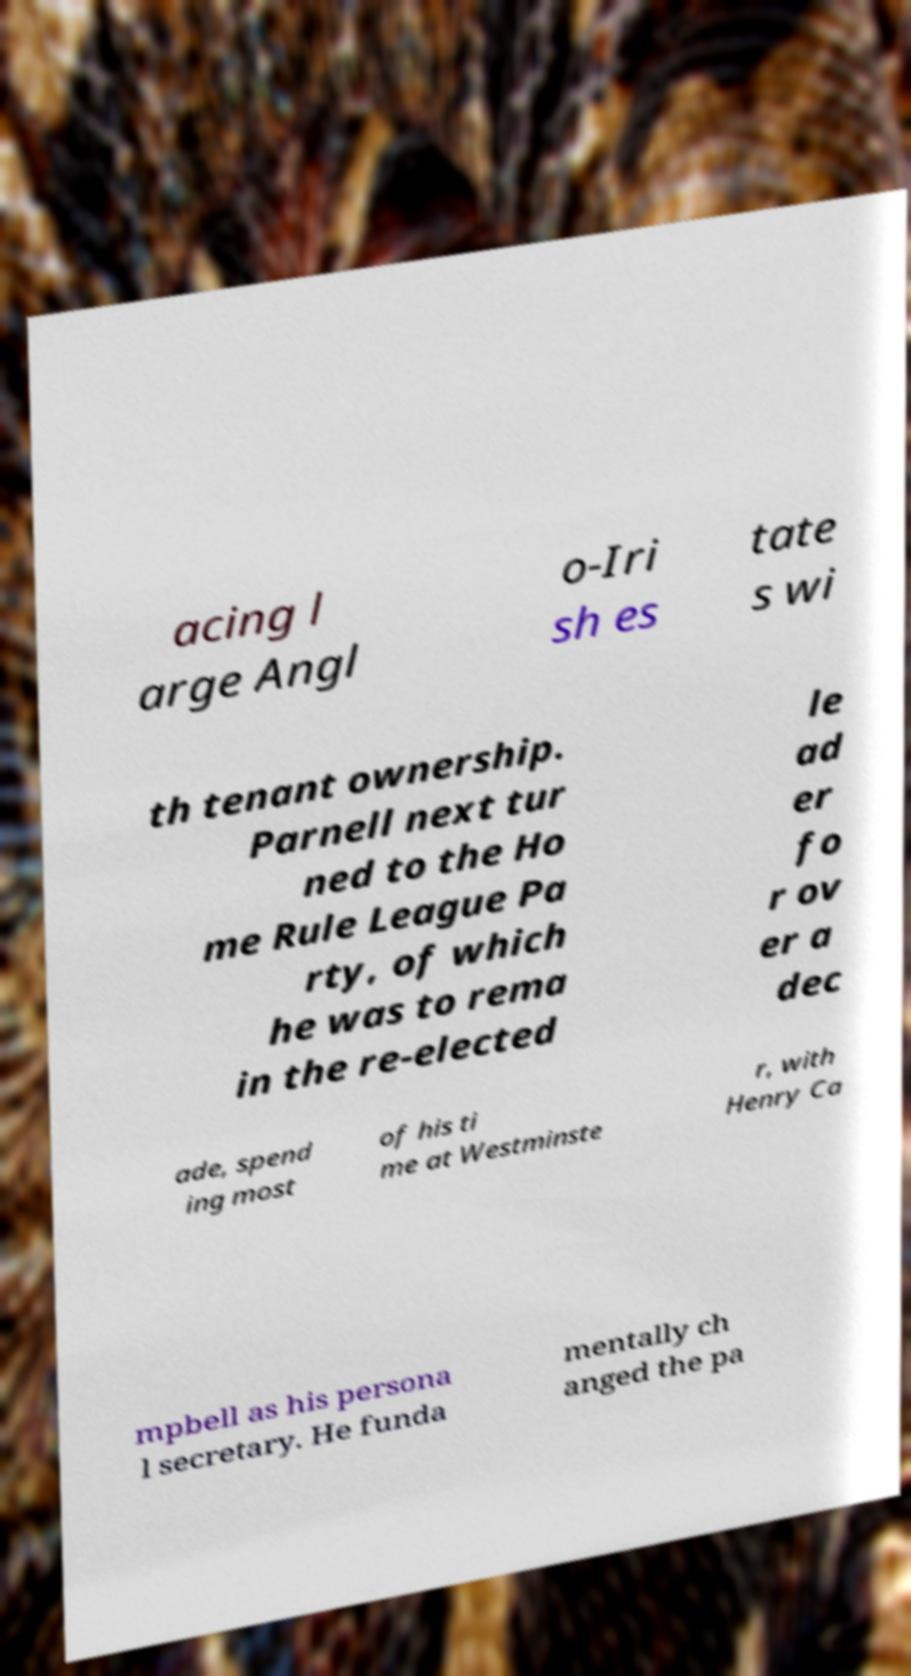Could you extract and type out the text from this image? acing l arge Angl o-Iri sh es tate s wi th tenant ownership. Parnell next tur ned to the Ho me Rule League Pa rty, of which he was to rema in the re-elected le ad er fo r ov er a dec ade, spend ing most of his ti me at Westminste r, with Henry Ca mpbell as his persona l secretary. He funda mentally ch anged the pa 